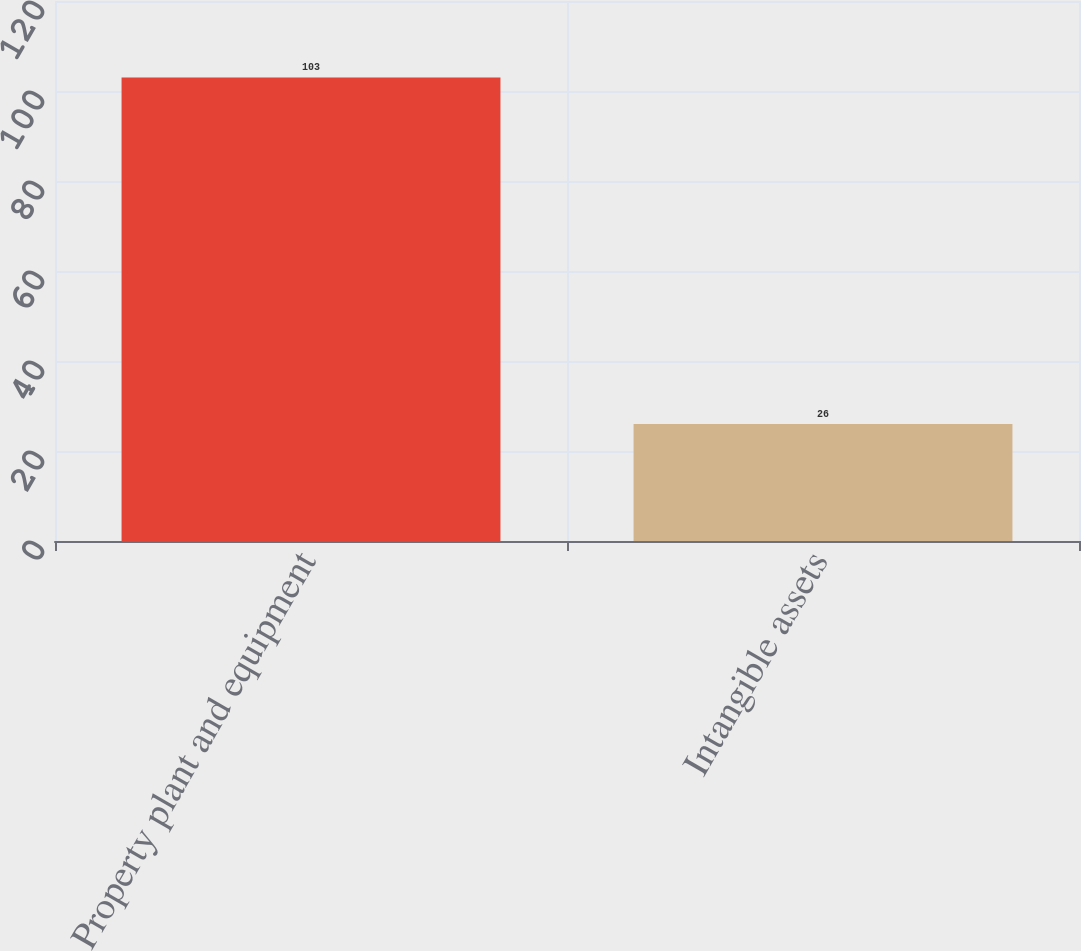Convert chart. <chart><loc_0><loc_0><loc_500><loc_500><bar_chart><fcel>Property plant and equipment<fcel>Intangible assets<nl><fcel>103<fcel>26<nl></chart> 